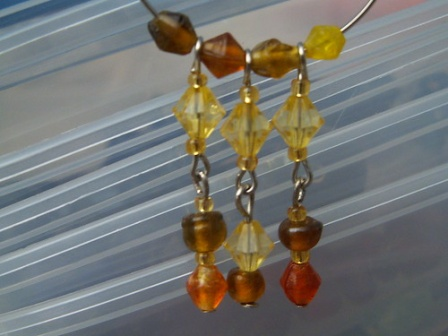If these earrings could tell a story, what would it be? If these earrings could tell a story, it would be a tale of craftsmanship and beauty. Made by a skilled artisan inspired by nature, each bead was carefully selected and combined to represent the colors of a serene sunset. The brown bead symbolizes the earth and its grounding presence; the amber yellow bead represents the last golden rays of the sunset illuminating the sky; and the red bead reflects the vibrant hues of the final moments of daylight. The silver chains linking the beads narrate a journey of connection and continuity, binding their individual stories into one coherent narrative. These earrings have seen many faces and heard many whispered secrets at twilight, carrying with them the essence of countless tranquil evenings. 